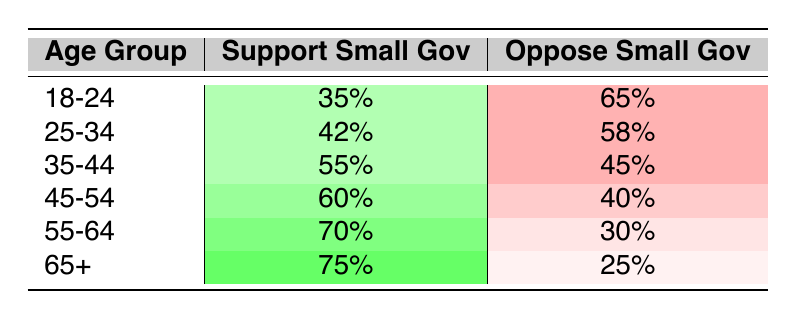What percentage of voters aged 18-24 support small government measures? According to the table, the percentage of voters aged 18-24 who support small government is listed under the "Support Small Gov" column for that age group, which is 35%.
Answer: 35% Which age group has the highest percentage of support for small government measures? The table indicates that the age group 65+ has the highest percentage of support for small government measures at 75%.
Answer: 65+ What is the difference in support between the age groups 25-34 and 45-54 for small government measures? To find the difference, subtract the percentage of support for the 25-34 age group (42%) from that of the 45-54 age group (60%). The difference is 60% - 42% = 18%.
Answer: 18% Is it true that more than half of voters in the age group 35-44 oppose small government measures? Looking at the 35-44 age group, the opposition percentage is 45%. Since 45% is not greater than 50%, the statement is false.
Answer: No What is the average percentage of support for small government among all age groups? To calculate the average, add up the support percentages of all age groups: 35% + 42% + 55% + 60% + 70% + 75% = 337%. There are 6 age groups, so the average is 337% / 6 = 56.17%.
Answer: Approximately 56.17% Which age group shows the smallest support for small government measures? Referring to the table, the age group 18-24 shows the smallest support for small government measures at 35%.
Answer: 18-24 What percentage of voters aged 55-64 oppose small government measures? The opposition percentage for the age group 55-64 is listed in the table, which is 30%.
Answer: 30% How many age groups show more than 50% support for small government measures? The age groups that show more than 50% support are 35-44, 45-54, 55-64, and 65+, totaling 4 age groups.
Answer: 4 